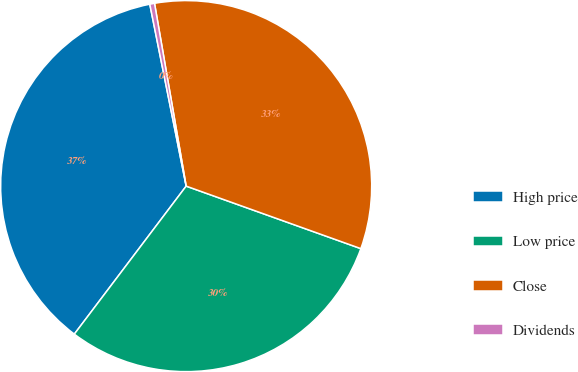Convert chart to OTSL. <chart><loc_0><loc_0><loc_500><loc_500><pie_chart><fcel>High price<fcel>Low price<fcel>Close<fcel>Dividends<nl><fcel>36.56%<fcel>29.83%<fcel>33.2%<fcel>0.41%<nl></chart> 